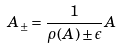<formula> <loc_0><loc_0><loc_500><loc_500>A _ { \pm } = \frac { 1 } { \rho ( A ) \pm \epsilon } A</formula> 